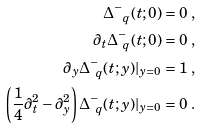Convert formula to latex. <formula><loc_0><loc_0><loc_500><loc_500>\Delta ^ { - } _ { \ q } ( t ; 0 ) & = 0 \ , \\ \partial _ { t } \Delta ^ { - } _ { \ q } ( t ; 0 ) & = 0 \ , \\ \partial _ { y } \Delta ^ { - } _ { \ q } ( t ; y ) | _ { y = 0 } & = 1 \ , \\ \left ( \frac { 1 } { 4 } \partial _ { t } ^ { 2 } - \partial _ { y } ^ { 2 } \right ) \Delta ^ { - } _ { \ q } ( t ; y ) | _ { y = 0 } & = 0 \ .</formula> 